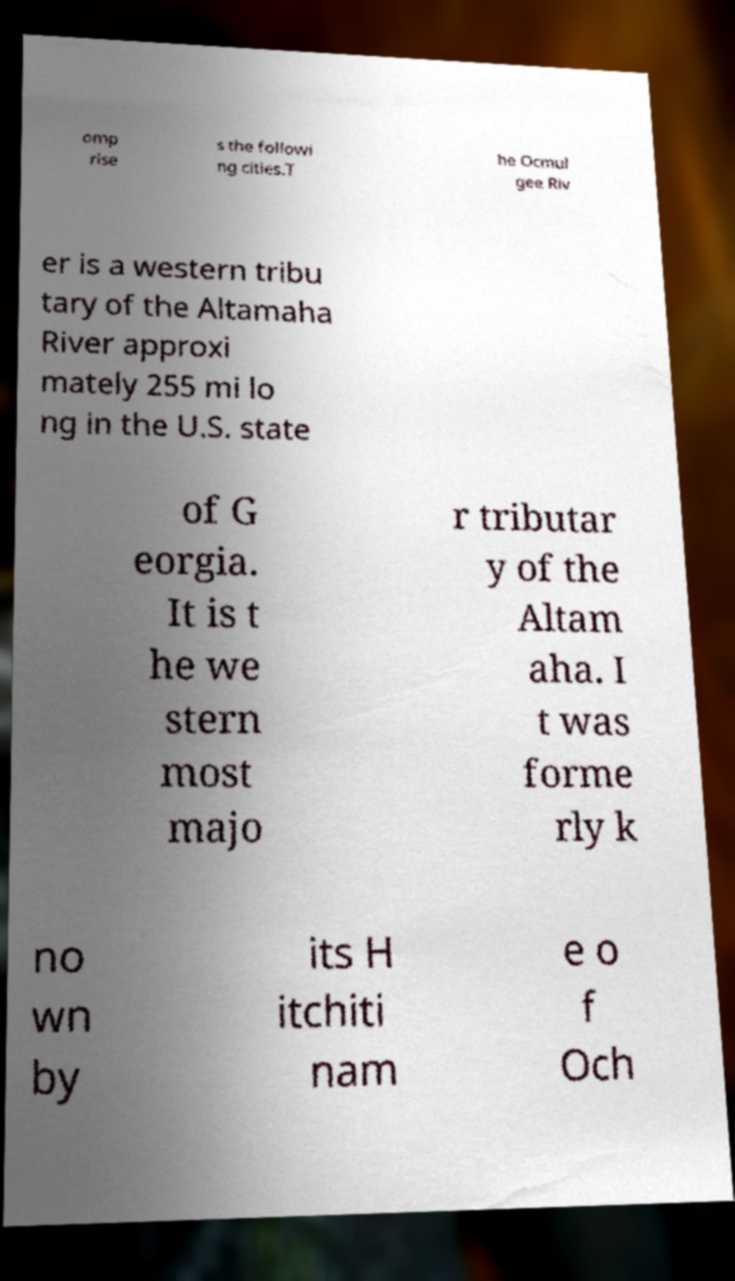Could you extract and type out the text from this image? omp rise s the followi ng cities.T he Ocmul gee Riv er is a western tribu tary of the Altamaha River approxi mately 255 mi lo ng in the U.S. state of G eorgia. It is t he we stern most majo r tributar y of the Altam aha. I t was forme rly k no wn by its H itchiti nam e o f Och 